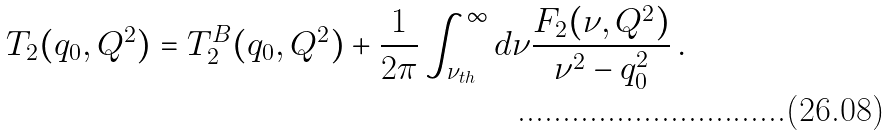Convert formula to latex. <formula><loc_0><loc_0><loc_500><loc_500>T _ { 2 } ( q _ { 0 } , Q ^ { 2 } ) & = T _ { 2 } ^ { B } ( q _ { 0 } , Q ^ { 2 } ) + \frac { 1 } { 2 \pi } \int _ { \nu _ { t h } } ^ { \infty } d \nu \frac { F _ { 2 } ( \nu , Q ^ { 2 } ) } { \nu ^ { 2 } - q _ { 0 } ^ { 2 } } \, .</formula> 